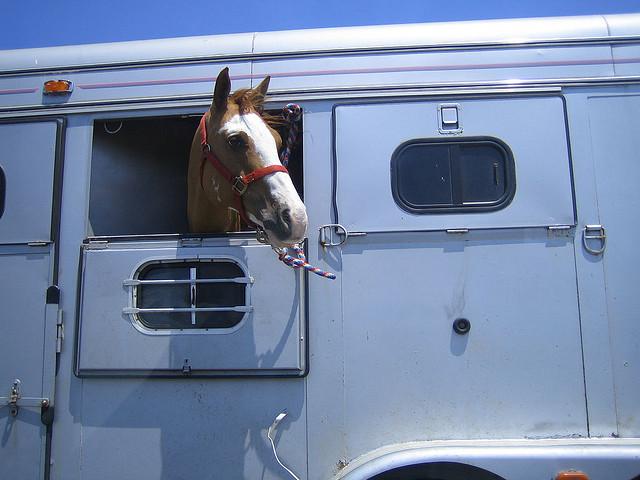What color is the horse harness?
Quick response, please. Red. What is the animal?
Short answer required. Horse. Is the horse entitled to roam freely from what you gather in the picture?
Write a very short answer. No. 